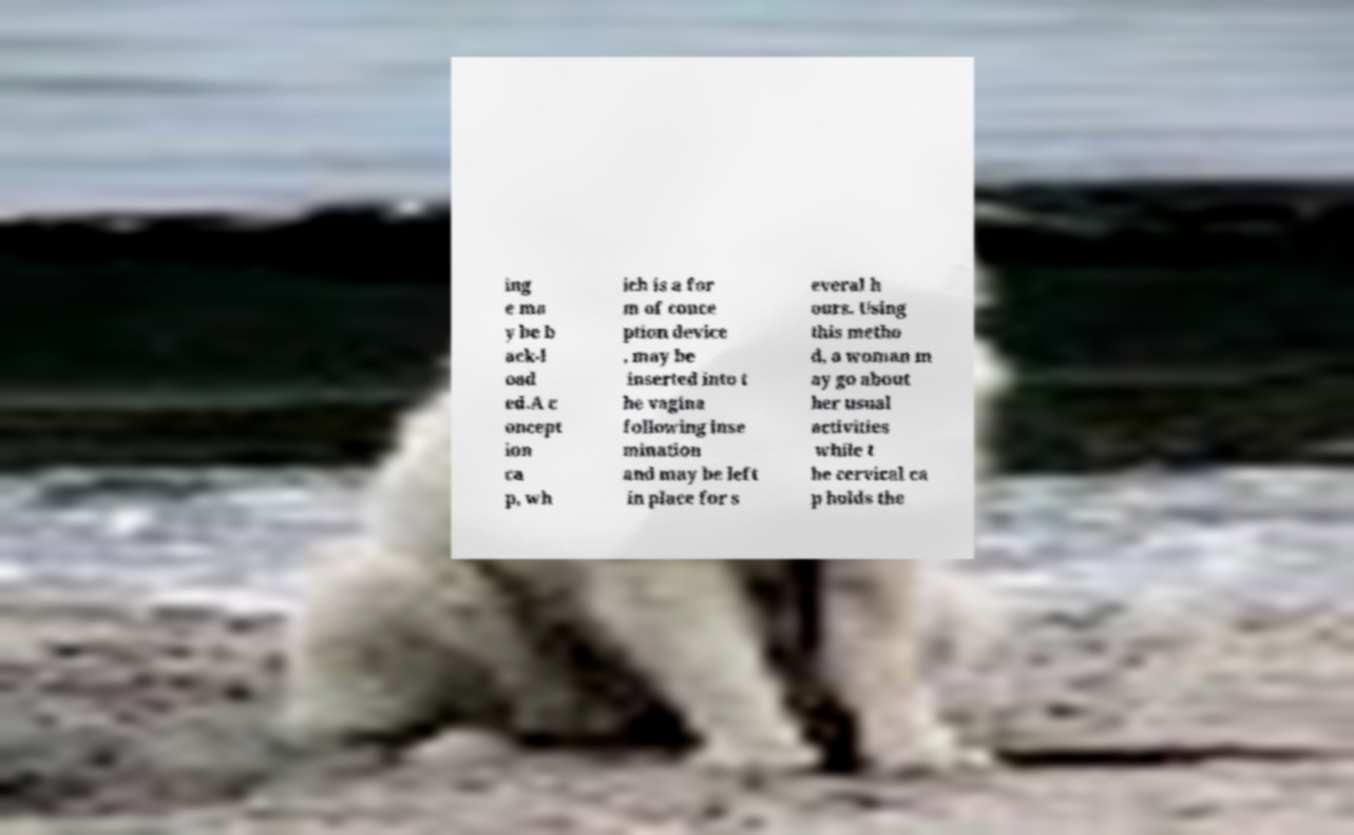Please read and relay the text visible in this image. What does it say? ing e ma y be b ack-l oad ed.A c oncept ion ca p, wh ich is a for m of conce ption device , may be inserted into t he vagina following inse mination and may be left in place for s everal h ours. Using this metho d, a woman m ay go about her usual activities while t he cervical ca p holds the 